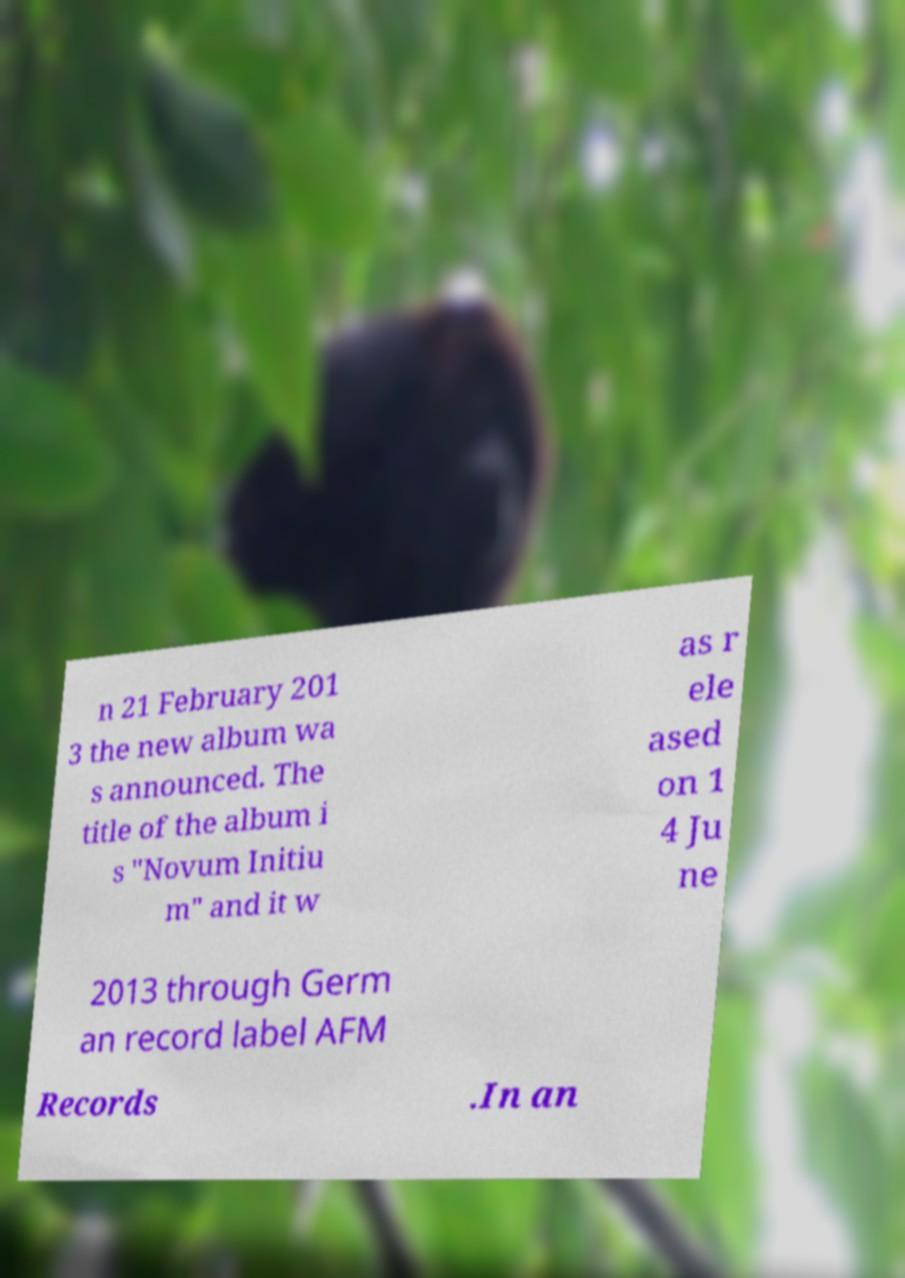What messages or text are displayed in this image? I need them in a readable, typed format. n 21 February 201 3 the new album wa s announced. The title of the album i s "Novum Initiu m" and it w as r ele ased on 1 4 Ju ne 2013 through Germ an record label AFM Records .In an 